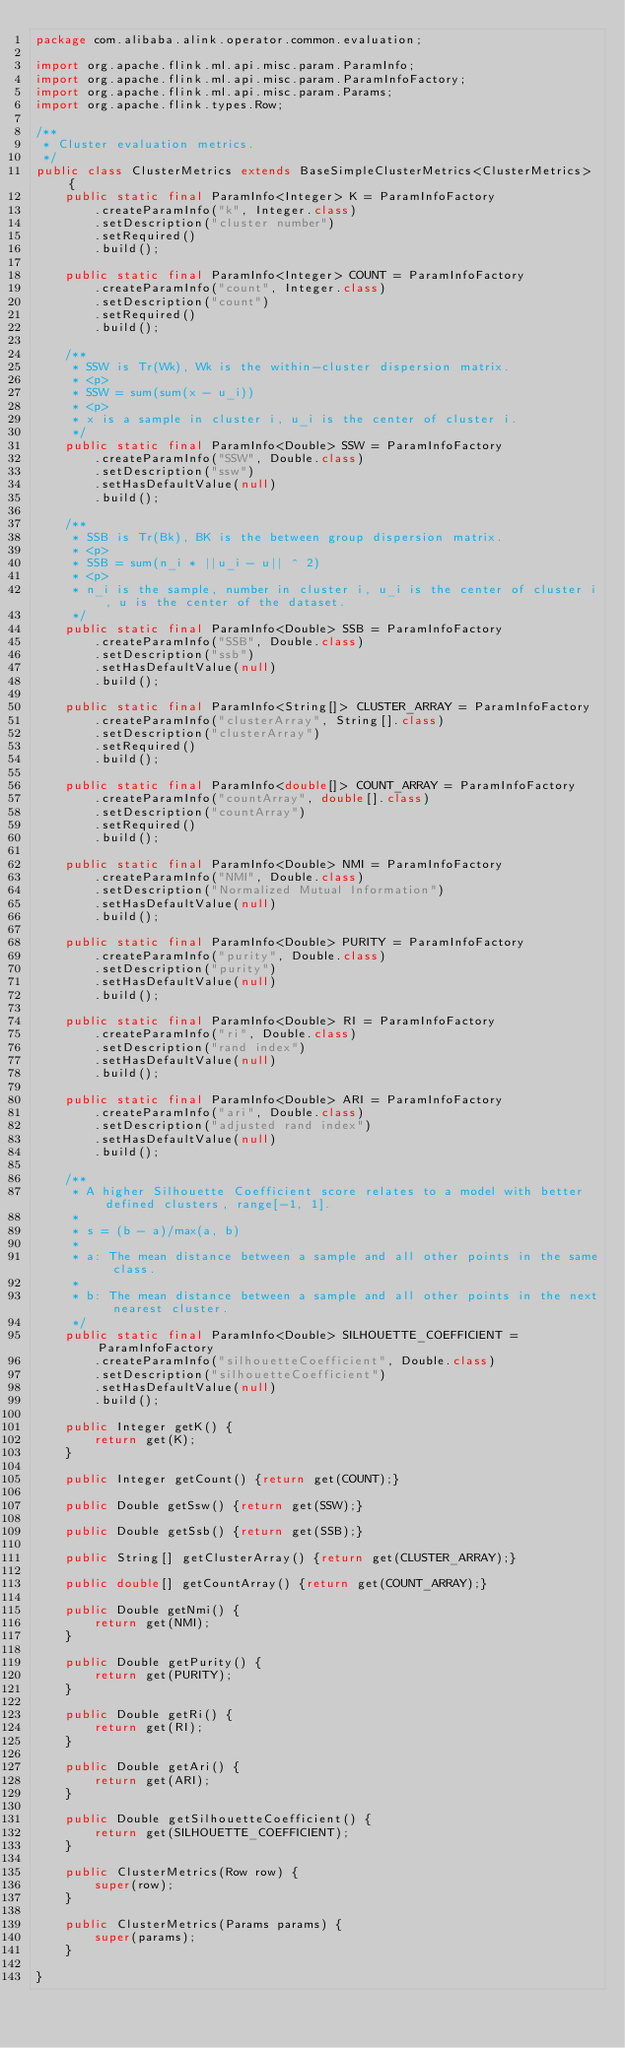<code> <loc_0><loc_0><loc_500><loc_500><_Java_>package com.alibaba.alink.operator.common.evaluation;

import org.apache.flink.ml.api.misc.param.ParamInfo;
import org.apache.flink.ml.api.misc.param.ParamInfoFactory;
import org.apache.flink.ml.api.misc.param.Params;
import org.apache.flink.types.Row;

/**
 * Cluster evaluation metrics.
 */
public class ClusterMetrics extends BaseSimpleClusterMetrics<ClusterMetrics> {
    public static final ParamInfo<Integer> K = ParamInfoFactory
        .createParamInfo("k", Integer.class)
        .setDescription("cluster number")
        .setRequired()
        .build();

    public static final ParamInfo<Integer> COUNT = ParamInfoFactory
        .createParamInfo("count", Integer.class)
        .setDescription("count")
        .setRequired()
        .build();

    /**
     * SSW is Tr(Wk), Wk is the within-cluster dispersion matrix.
     * <p>
     * SSW = sum(sum(x - u_i))
     * <p>
     * x is a sample in cluster i, u_i is the center of cluster i.
     */
    public static final ParamInfo<Double> SSW = ParamInfoFactory
        .createParamInfo("SSW", Double.class)
        .setDescription("ssw")
        .setHasDefaultValue(null)
        .build();

    /**
     * SSB is Tr(Bk), BK is the between group dispersion matrix.
     * <p>
     * SSB = sum(n_i * ||u_i - u|| ^ 2)
     * <p>
     * n_i is the sample, number in cluster i, u_i is the center of cluster i, u is the center of the dataset.
     */
    public static final ParamInfo<Double> SSB = ParamInfoFactory
        .createParamInfo("SSB", Double.class)
        .setDescription("ssb")
        .setHasDefaultValue(null)
        .build();

    public static final ParamInfo<String[]> CLUSTER_ARRAY = ParamInfoFactory
        .createParamInfo("clusterArray", String[].class)
        .setDescription("clusterArray")
        .setRequired()
        .build();

    public static final ParamInfo<double[]> COUNT_ARRAY = ParamInfoFactory
        .createParamInfo("countArray", double[].class)
        .setDescription("countArray")
        .setRequired()
        .build();

    public static final ParamInfo<Double> NMI = ParamInfoFactory
        .createParamInfo("NMI", Double.class)
        .setDescription("Normalized Mutual Information")
        .setHasDefaultValue(null)
        .build();

    public static final ParamInfo<Double> PURITY = ParamInfoFactory
        .createParamInfo("purity", Double.class)
        .setDescription("purity")
        .setHasDefaultValue(null)
        .build();

    public static final ParamInfo<Double> RI = ParamInfoFactory
        .createParamInfo("ri", Double.class)
        .setDescription("rand index")
        .setHasDefaultValue(null)
        .build();

    public static final ParamInfo<Double> ARI = ParamInfoFactory
        .createParamInfo("ari", Double.class)
        .setDescription("adjusted rand index")
        .setHasDefaultValue(null)
        .build();

    /**
     * A higher Silhouette Coefficient score relates to a model with better defined clusters, range[-1, 1].
     *
     * s = (b - a)/max(a, b)
     *
     * a: The mean distance between a sample and all other points in the same class.
     *
     * b: The mean distance between a sample and all other points in the next nearest cluster.
     */
    public static final ParamInfo<Double> SILHOUETTE_COEFFICIENT = ParamInfoFactory
        .createParamInfo("silhouetteCoefficient", Double.class)
        .setDescription("silhouetteCoefficient")
        .setHasDefaultValue(null)
        .build();

    public Integer getK() {
        return get(K);
    }

    public Integer getCount() {return get(COUNT);}

    public Double getSsw() {return get(SSW);}

    public Double getSsb() {return get(SSB);}

    public String[] getClusterArray() {return get(CLUSTER_ARRAY);}

    public double[] getCountArray() {return get(COUNT_ARRAY);}

    public Double getNmi() {
        return get(NMI);
    }

    public Double getPurity() {
        return get(PURITY);
    }

    public Double getRi() {
        return get(RI);
    }

    public Double getAri() {
        return get(ARI);
    }

    public Double getSilhouetteCoefficient() {
        return get(SILHOUETTE_COEFFICIENT);
    }

    public ClusterMetrics(Row row) {
        super(row);
    }

    public ClusterMetrics(Params params) {
        super(params);
    }

}
</code> 